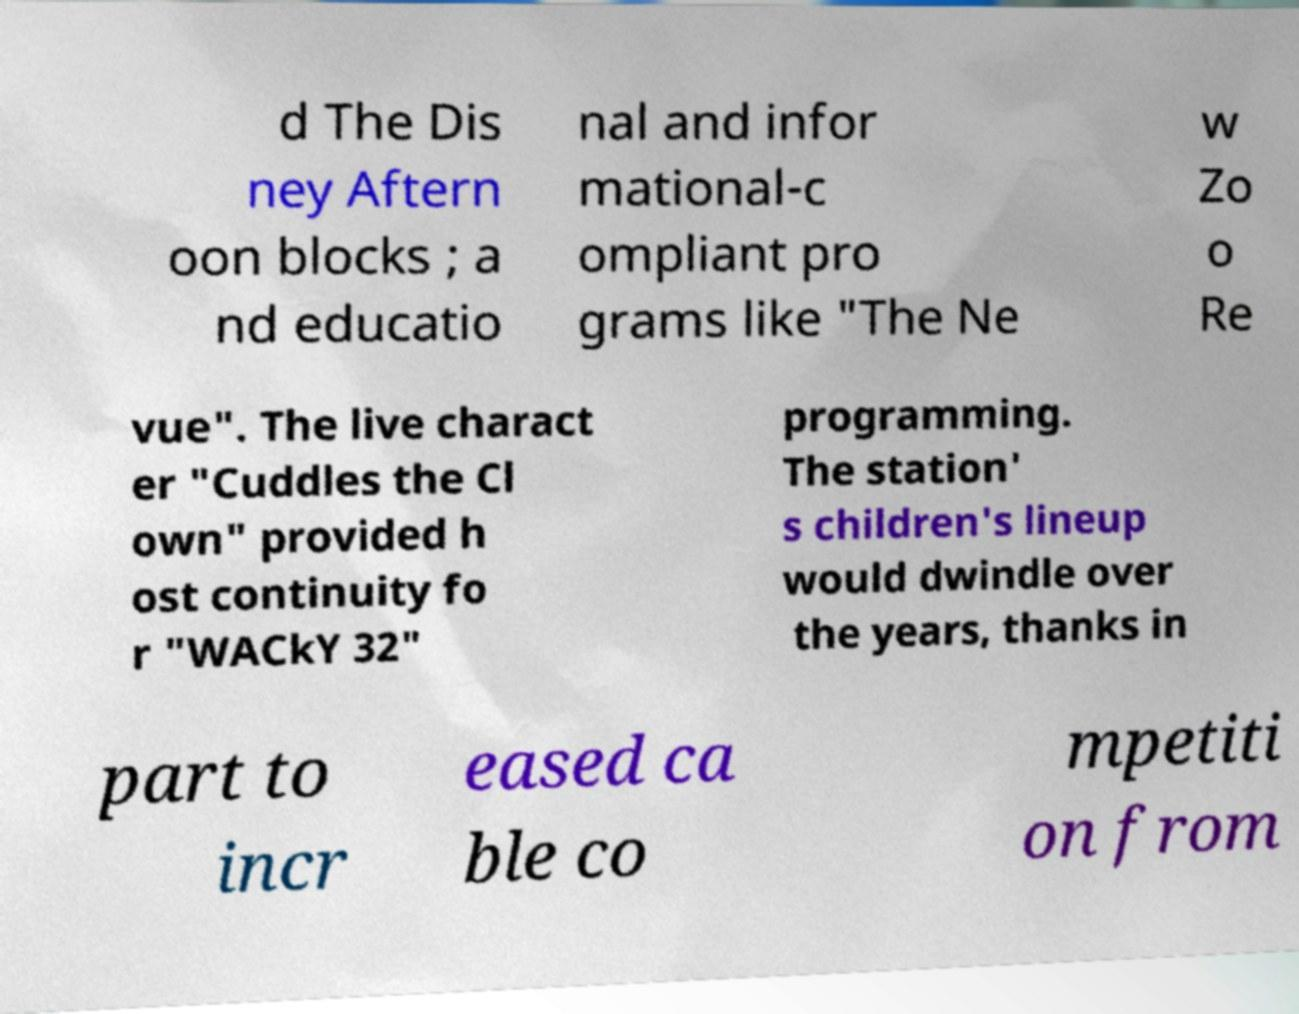Could you assist in decoding the text presented in this image and type it out clearly? d The Dis ney Aftern oon blocks ; a nd educatio nal and infor mational-c ompliant pro grams like "The Ne w Zo o Re vue". The live charact er "Cuddles the Cl own" provided h ost continuity fo r "WACkY 32" programming. The station' s children's lineup would dwindle over the years, thanks in part to incr eased ca ble co mpetiti on from 